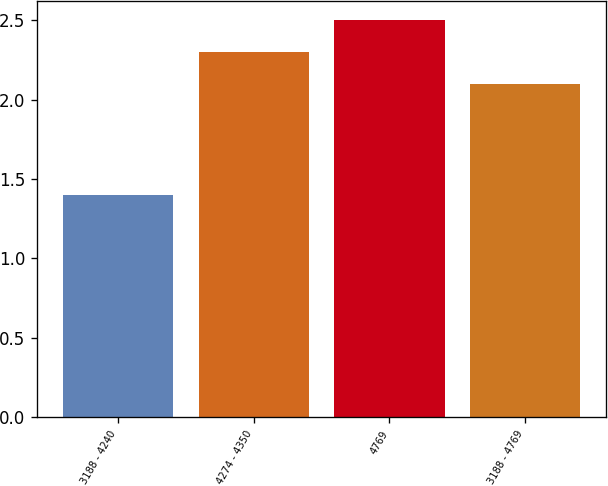<chart> <loc_0><loc_0><loc_500><loc_500><bar_chart><fcel>3188 - 4240<fcel>4274 - 4350<fcel>4769<fcel>3188 - 4769<nl><fcel>1.4<fcel>2.3<fcel>2.5<fcel>2.1<nl></chart> 